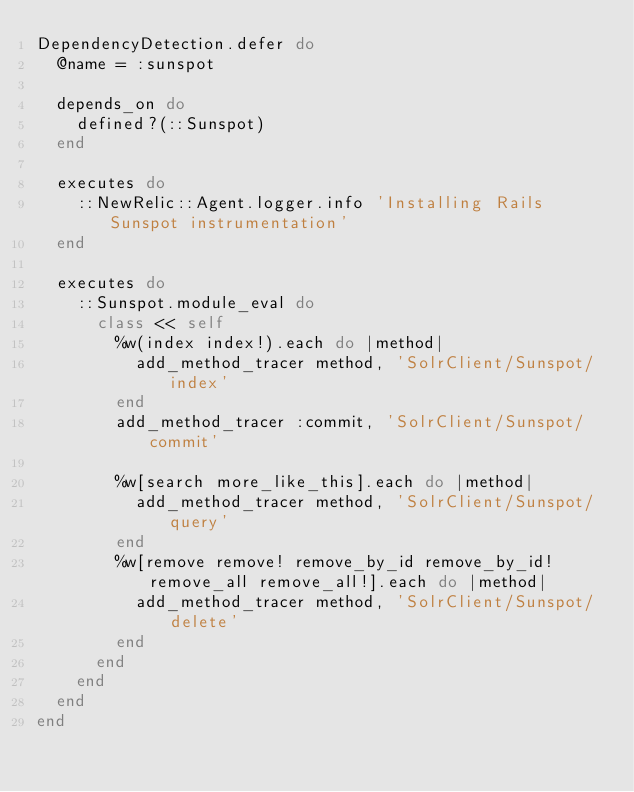Convert code to text. <code><loc_0><loc_0><loc_500><loc_500><_Ruby_>DependencyDetection.defer do
  @name = :sunspot

  depends_on do
    defined?(::Sunspot)
  end

  executes do
    ::NewRelic::Agent.logger.info 'Installing Rails Sunspot instrumentation'
  end
  
  executes do
    ::Sunspot.module_eval do
      class << self
        %w(index index!).each do |method|
          add_method_tracer method, 'SolrClient/Sunspot/index'
        end
        add_method_tracer :commit, 'SolrClient/Sunspot/commit'

        %w[search more_like_this].each do |method|
          add_method_tracer method, 'SolrClient/Sunspot/query'
        end
        %w[remove remove! remove_by_id remove_by_id! remove_all remove_all!].each do |method|
          add_method_tracer method, 'SolrClient/Sunspot/delete'
        end
      end
    end
  end
end
</code> 